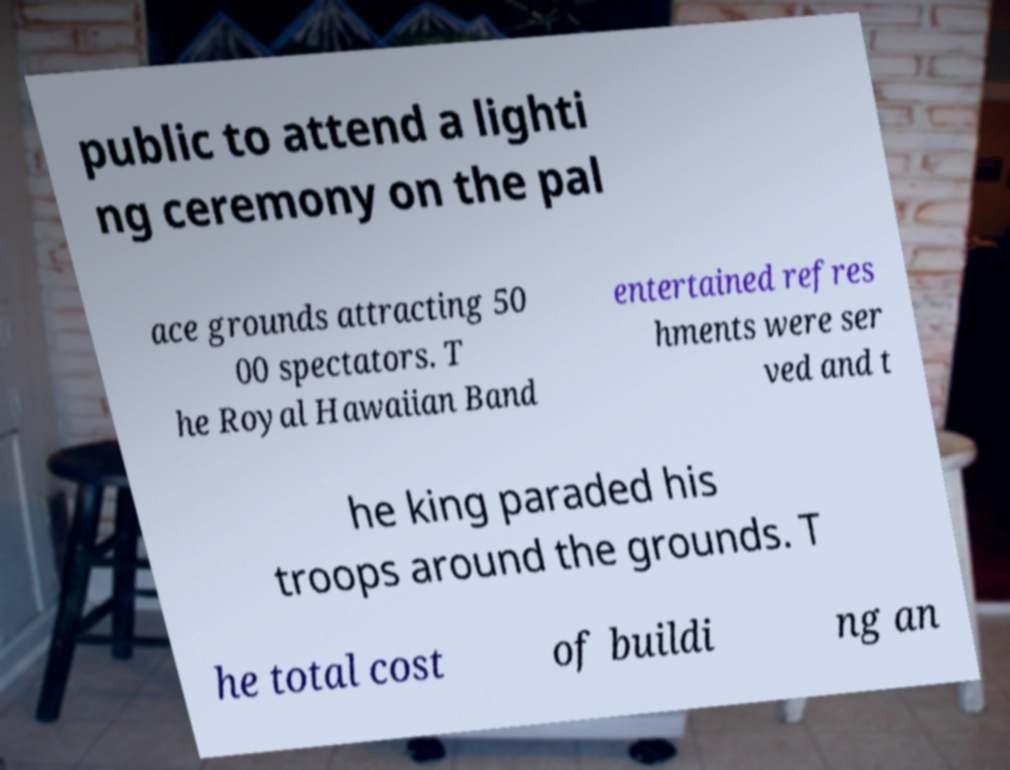I need the written content from this picture converted into text. Can you do that? public to attend a lighti ng ceremony on the pal ace grounds attracting 50 00 spectators. T he Royal Hawaiian Band entertained refres hments were ser ved and t he king paraded his troops around the grounds. T he total cost of buildi ng an 